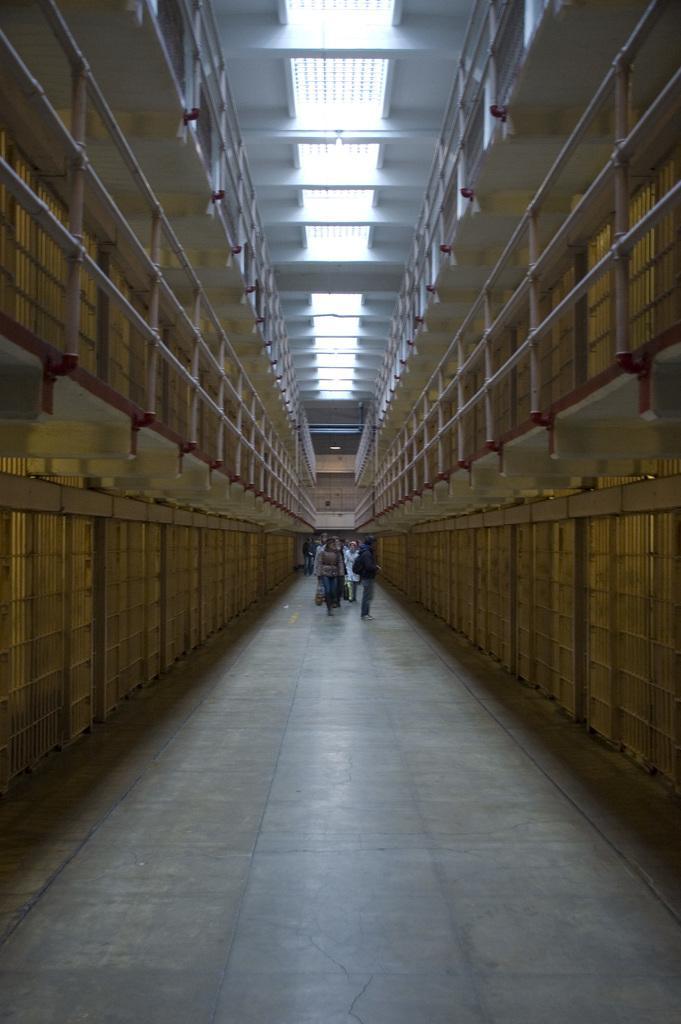In one or two sentences, can you explain what this image depicts? In the image there are few people walking on the floor and around the floor there are railings and there are lights to the roof. 